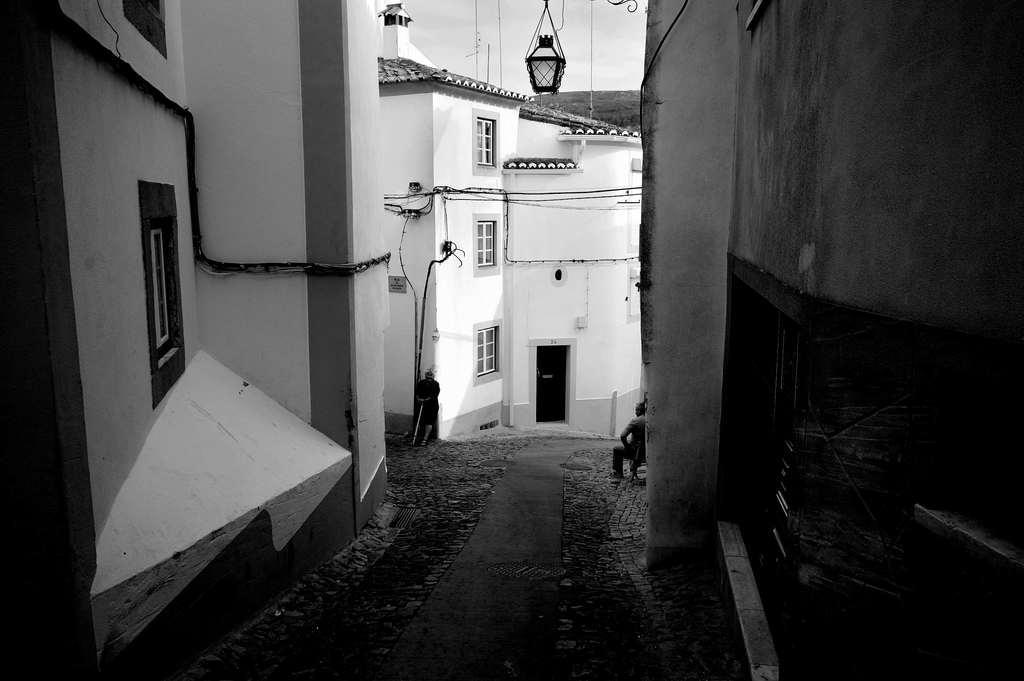How would you summarize this image in a sentence or two? This is a black and white image. In this picture we can see buildings, windows, door, two persons, wires, light. At the top of the image we can see the sky. At the bottom of the image we can see the road. 